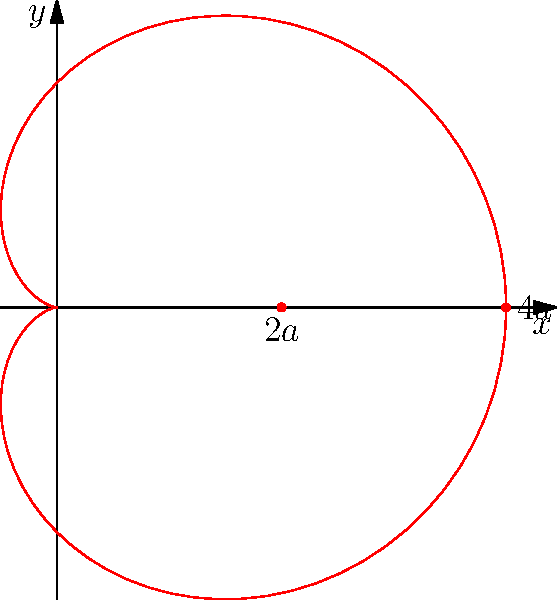Examine the polar graph of the cardioid given by the equation $r = 2a(1 + \cos\theta)$, where $a > 0$. Determine the maximum distance of any point on the curve from the origin. Express your answer in terms of $a$. To find the maximum distance from the origin, we need to follow these steps:

1) The distance from the origin in polar coordinates is given by $r$.

2) The equation of the cardioid is $r = 2a(1 + \cos\theta)$.

3) To find the maximum value of $r$, we need to consider when $\cos\theta$ is at its maximum.

4) We know that the maximum value of $\cos\theta$ is 1, which occurs when $\theta = 0$ or $2\pi$.

5) Substituting this into the equation:

   $r_{max} = 2a(1 + 1) = 2a(2) = 4a$

6) Therefore, the maximum distance from the origin is $4a$.

7) This corresponds to the rightmost point on the cardioid in the graph.

Remember, Doug, this is straightforward if you recall the properties of cosine and understand how to interpret polar equations. No need for skepticism here - the math speaks for itself.
Answer: $4a$ 